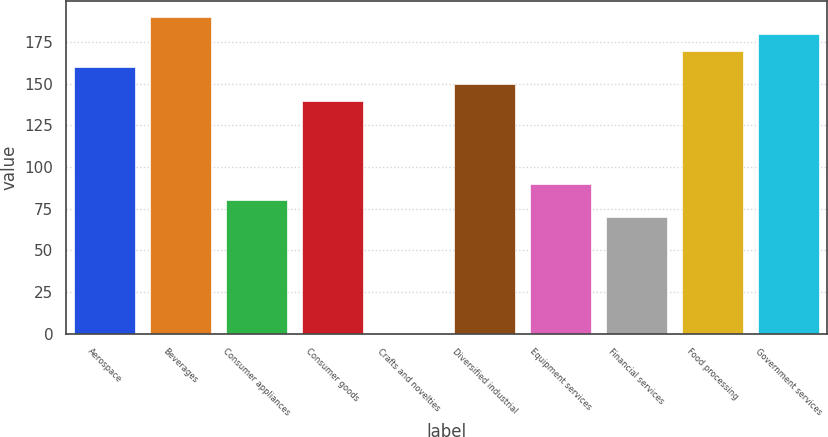Convert chart to OTSL. <chart><loc_0><loc_0><loc_500><loc_500><bar_chart><fcel>Aerospace<fcel>Beverages<fcel>Consumer appliances<fcel>Consumer goods<fcel>Crafts and novelties<fcel>Diversified industrial<fcel>Equipment services<fcel>Financial services<fcel>Food processing<fcel>Government services<nl><fcel>159.94<fcel>189.91<fcel>80.02<fcel>139.96<fcel>0.1<fcel>149.95<fcel>90.01<fcel>70.03<fcel>169.93<fcel>179.92<nl></chart> 